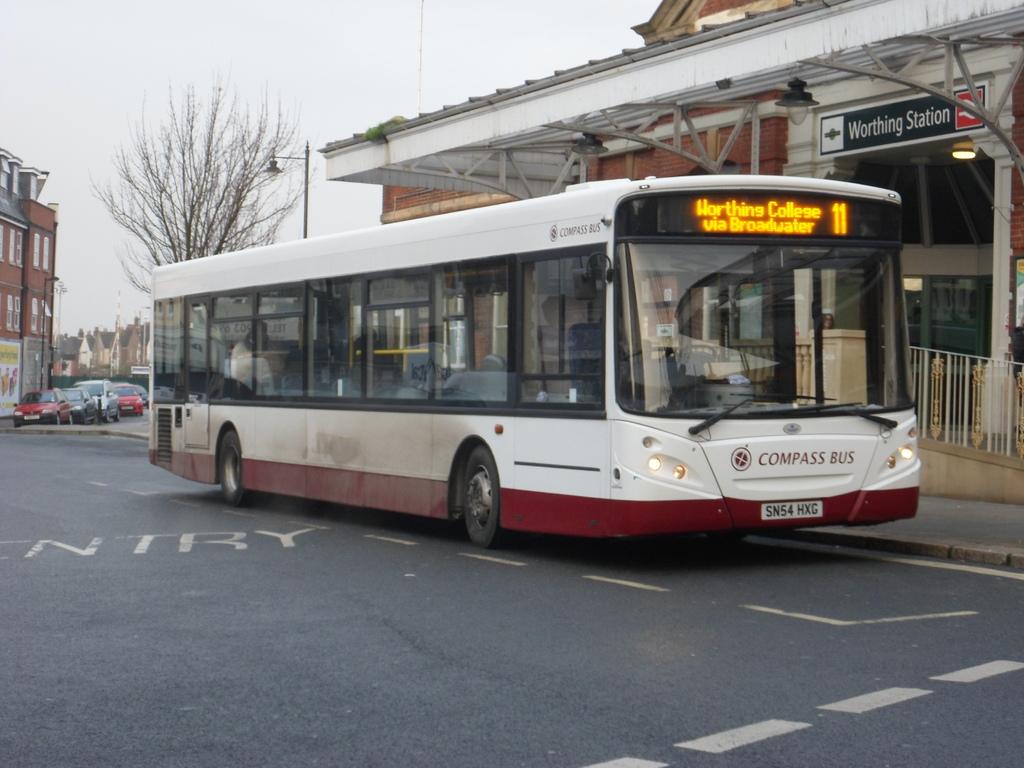What is the license plate for this bus?
Your response must be concise. Sn54 hxg. What station is this?
Your answer should be very brief. Worthing. 